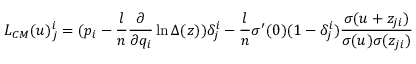Convert formula to latex. <formula><loc_0><loc_0><loc_500><loc_500>L _ { C M } ( u ) _ { j } ^ { i } = ( p _ { i } - \frac { l } { n } \frac { \partial } { \partial q _ { i } } \ln \Delta ( z ) ) \delta _ { j } ^ { i } - \frac { l } { n } \sigma ^ { \prime } ( 0 ) ( 1 - \delta _ { j } ^ { i } ) \frac { \sigma ( u + z _ { j i } ) } { \sigma ( u ) \sigma ( z _ { j i } ) }</formula> 